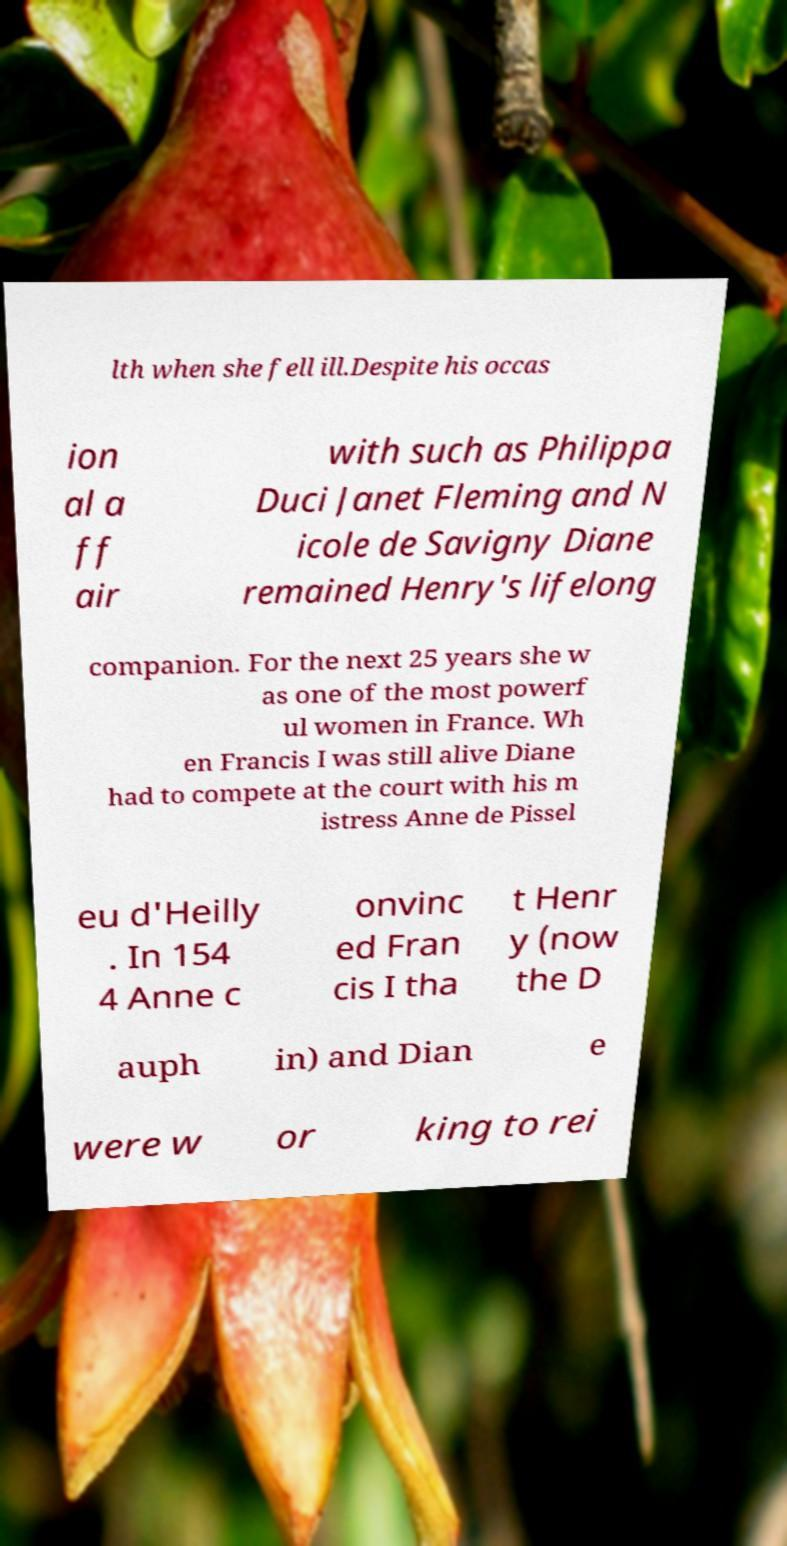Can you accurately transcribe the text from the provided image for me? lth when she fell ill.Despite his occas ion al a ff air with such as Philippa Duci Janet Fleming and N icole de Savigny Diane remained Henry's lifelong companion. For the next 25 years she w as one of the most powerf ul women in France. Wh en Francis I was still alive Diane had to compete at the court with his m istress Anne de Pissel eu d'Heilly . In 154 4 Anne c onvinc ed Fran cis I tha t Henr y (now the D auph in) and Dian e were w or king to rei 